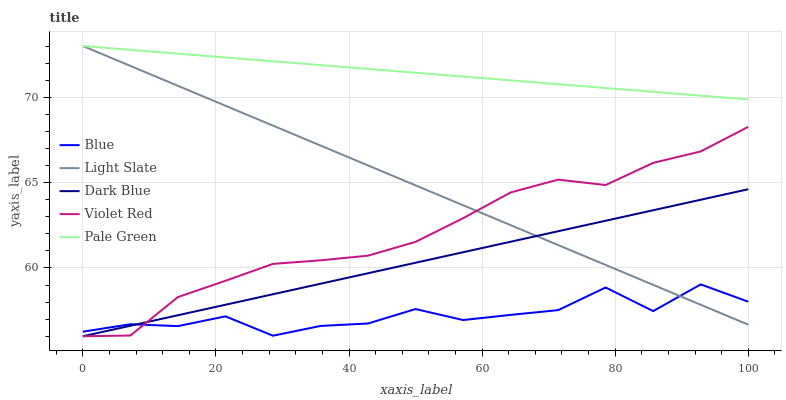Does Blue have the minimum area under the curve?
Answer yes or no. Yes. Does Pale Green have the maximum area under the curve?
Answer yes or no. Yes. Does Light Slate have the minimum area under the curve?
Answer yes or no. No. Does Light Slate have the maximum area under the curve?
Answer yes or no. No. Is Dark Blue the smoothest?
Answer yes or no. Yes. Is Blue the roughest?
Answer yes or no. Yes. Is Light Slate the smoothest?
Answer yes or no. No. Is Light Slate the roughest?
Answer yes or no. No. Does Light Slate have the lowest value?
Answer yes or no. No. Does Pale Green have the highest value?
Answer yes or no. Yes. Does Violet Red have the highest value?
Answer yes or no. No. Is Violet Red less than Pale Green?
Answer yes or no. Yes. Is Pale Green greater than Violet Red?
Answer yes or no. Yes. Does Dark Blue intersect Violet Red?
Answer yes or no. Yes. Is Dark Blue less than Violet Red?
Answer yes or no. No. Is Dark Blue greater than Violet Red?
Answer yes or no. No. Does Violet Red intersect Pale Green?
Answer yes or no. No. 